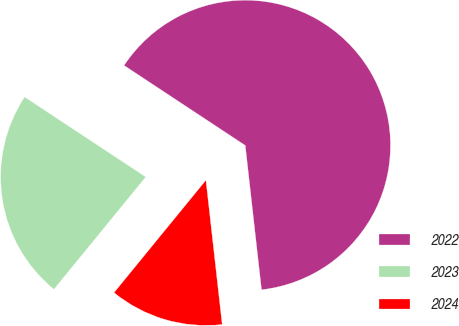Convert chart to OTSL. <chart><loc_0><loc_0><loc_500><loc_500><pie_chart><fcel>2022<fcel>2023<fcel>2024<nl><fcel>63.93%<fcel>23.38%<fcel>12.69%<nl></chart> 